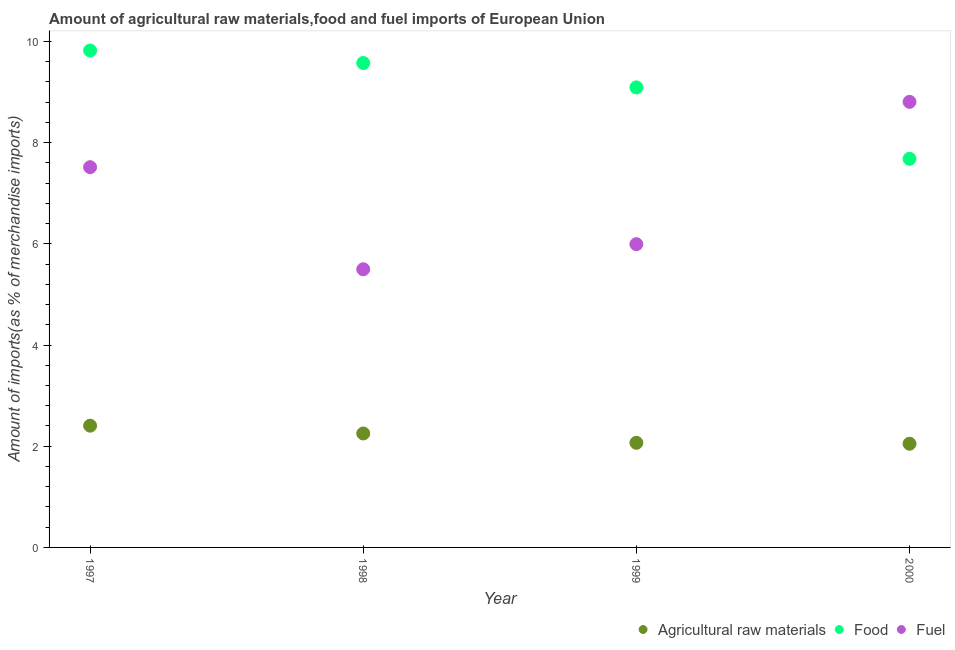Is the number of dotlines equal to the number of legend labels?
Give a very brief answer. Yes. What is the percentage of raw materials imports in 2000?
Your answer should be very brief. 2.05. Across all years, what is the maximum percentage of fuel imports?
Give a very brief answer. 8.81. Across all years, what is the minimum percentage of raw materials imports?
Your answer should be compact. 2.05. In which year was the percentage of food imports maximum?
Your response must be concise. 1997. In which year was the percentage of fuel imports minimum?
Keep it short and to the point. 1998. What is the total percentage of fuel imports in the graph?
Keep it short and to the point. 27.81. What is the difference between the percentage of raw materials imports in 1997 and that in 1998?
Provide a succinct answer. 0.15. What is the difference between the percentage of fuel imports in 1997 and the percentage of food imports in 2000?
Provide a short and direct response. -0.17. What is the average percentage of food imports per year?
Make the answer very short. 9.04. In the year 1998, what is the difference between the percentage of raw materials imports and percentage of food imports?
Make the answer very short. -7.32. In how many years, is the percentage of food imports greater than 2.8 %?
Ensure brevity in your answer.  4. What is the ratio of the percentage of fuel imports in 1997 to that in 1999?
Offer a terse response. 1.25. Is the difference between the percentage of raw materials imports in 1998 and 2000 greater than the difference between the percentage of fuel imports in 1998 and 2000?
Provide a succinct answer. Yes. What is the difference between the highest and the second highest percentage of fuel imports?
Your answer should be compact. 1.29. What is the difference between the highest and the lowest percentage of raw materials imports?
Give a very brief answer. 0.36. In how many years, is the percentage of fuel imports greater than the average percentage of fuel imports taken over all years?
Your answer should be compact. 2. Is it the case that in every year, the sum of the percentage of raw materials imports and percentage of food imports is greater than the percentage of fuel imports?
Offer a terse response. Yes. Is the percentage of fuel imports strictly greater than the percentage of raw materials imports over the years?
Your response must be concise. Yes. Is the percentage of food imports strictly less than the percentage of fuel imports over the years?
Give a very brief answer. No. How many dotlines are there?
Ensure brevity in your answer.  3. What is the difference between two consecutive major ticks on the Y-axis?
Your response must be concise. 2. Are the values on the major ticks of Y-axis written in scientific E-notation?
Make the answer very short. No. Does the graph contain any zero values?
Provide a short and direct response. No. Does the graph contain grids?
Provide a succinct answer. No. What is the title of the graph?
Make the answer very short. Amount of agricultural raw materials,food and fuel imports of European Union. What is the label or title of the Y-axis?
Provide a succinct answer. Amount of imports(as % of merchandise imports). What is the Amount of imports(as % of merchandise imports) of Agricultural raw materials in 1997?
Offer a very short reply. 2.41. What is the Amount of imports(as % of merchandise imports) in Food in 1997?
Your response must be concise. 9.82. What is the Amount of imports(as % of merchandise imports) of Fuel in 1997?
Give a very brief answer. 7.52. What is the Amount of imports(as % of merchandise imports) of Agricultural raw materials in 1998?
Offer a very short reply. 2.25. What is the Amount of imports(as % of merchandise imports) in Food in 1998?
Provide a succinct answer. 9.57. What is the Amount of imports(as % of merchandise imports) of Fuel in 1998?
Your response must be concise. 5.5. What is the Amount of imports(as % of merchandise imports) in Agricultural raw materials in 1999?
Provide a succinct answer. 2.07. What is the Amount of imports(as % of merchandise imports) in Food in 1999?
Provide a short and direct response. 9.09. What is the Amount of imports(as % of merchandise imports) of Fuel in 1999?
Give a very brief answer. 5.99. What is the Amount of imports(as % of merchandise imports) of Agricultural raw materials in 2000?
Provide a succinct answer. 2.05. What is the Amount of imports(as % of merchandise imports) in Food in 2000?
Provide a short and direct response. 7.68. What is the Amount of imports(as % of merchandise imports) in Fuel in 2000?
Your answer should be very brief. 8.81. Across all years, what is the maximum Amount of imports(as % of merchandise imports) in Agricultural raw materials?
Offer a terse response. 2.41. Across all years, what is the maximum Amount of imports(as % of merchandise imports) in Food?
Make the answer very short. 9.82. Across all years, what is the maximum Amount of imports(as % of merchandise imports) in Fuel?
Make the answer very short. 8.81. Across all years, what is the minimum Amount of imports(as % of merchandise imports) of Agricultural raw materials?
Give a very brief answer. 2.05. Across all years, what is the minimum Amount of imports(as % of merchandise imports) in Food?
Your response must be concise. 7.68. Across all years, what is the minimum Amount of imports(as % of merchandise imports) in Fuel?
Provide a succinct answer. 5.5. What is the total Amount of imports(as % of merchandise imports) in Agricultural raw materials in the graph?
Your response must be concise. 8.78. What is the total Amount of imports(as % of merchandise imports) in Food in the graph?
Give a very brief answer. 36.17. What is the total Amount of imports(as % of merchandise imports) of Fuel in the graph?
Offer a very short reply. 27.81. What is the difference between the Amount of imports(as % of merchandise imports) in Agricultural raw materials in 1997 and that in 1998?
Keep it short and to the point. 0.15. What is the difference between the Amount of imports(as % of merchandise imports) in Food in 1997 and that in 1998?
Your answer should be very brief. 0.25. What is the difference between the Amount of imports(as % of merchandise imports) of Fuel in 1997 and that in 1998?
Offer a terse response. 2.02. What is the difference between the Amount of imports(as % of merchandise imports) of Agricultural raw materials in 1997 and that in 1999?
Offer a terse response. 0.34. What is the difference between the Amount of imports(as % of merchandise imports) in Food in 1997 and that in 1999?
Ensure brevity in your answer.  0.73. What is the difference between the Amount of imports(as % of merchandise imports) of Fuel in 1997 and that in 1999?
Provide a succinct answer. 1.52. What is the difference between the Amount of imports(as % of merchandise imports) of Agricultural raw materials in 1997 and that in 2000?
Keep it short and to the point. 0.36. What is the difference between the Amount of imports(as % of merchandise imports) in Food in 1997 and that in 2000?
Make the answer very short. 2.14. What is the difference between the Amount of imports(as % of merchandise imports) in Fuel in 1997 and that in 2000?
Provide a succinct answer. -1.29. What is the difference between the Amount of imports(as % of merchandise imports) of Agricultural raw materials in 1998 and that in 1999?
Provide a short and direct response. 0.18. What is the difference between the Amount of imports(as % of merchandise imports) of Food in 1998 and that in 1999?
Keep it short and to the point. 0.48. What is the difference between the Amount of imports(as % of merchandise imports) in Fuel in 1998 and that in 1999?
Your answer should be very brief. -0.5. What is the difference between the Amount of imports(as % of merchandise imports) in Agricultural raw materials in 1998 and that in 2000?
Your answer should be very brief. 0.2. What is the difference between the Amount of imports(as % of merchandise imports) of Food in 1998 and that in 2000?
Ensure brevity in your answer.  1.89. What is the difference between the Amount of imports(as % of merchandise imports) of Fuel in 1998 and that in 2000?
Offer a very short reply. -3.31. What is the difference between the Amount of imports(as % of merchandise imports) in Agricultural raw materials in 1999 and that in 2000?
Offer a terse response. 0.02. What is the difference between the Amount of imports(as % of merchandise imports) of Food in 1999 and that in 2000?
Provide a succinct answer. 1.41. What is the difference between the Amount of imports(as % of merchandise imports) in Fuel in 1999 and that in 2000?
Make the answer very short. -2.81. What is the difference between the Amount of imports(as % of merchandise imports) in Agricultural raw materials in 1997 and the Amount of imports(as % of merchandise imports) in Food in 1998?
Your answer should be very brief. -7.17. What is the difference between the Amount of imports(as % of merchandise imports) of Agricultural raw materials in 1997 and the Amount of imports(as % of merchandise imports) of Fuel in 1998?
Offer a terse response. -3.09. What is the difference between the Amount of imports(as % of merchandise imports) in Food in 1997 and the Amount of imports(as % of merchandise imports) in Fuel in 1998?
Ensure brevity in your answer.  4.32. What is the difference between the Amount of imports(as % of merchandise imports) in Agricultural raw materials in 1997 and the Amount of imports(as % of merchandise imports) in Food in 1999?
Your response must be concise. -6.69. What is the difference between the Amount of imports(as % of merchandise imports) of Agricultural raw materials in 1997 and the Amount of imports(as % of merchandise imports) of Fuel in 1999?
Your answer should be very brief. -3.59. What is the difference between the Amount of imports(as % of merchandise imports) of Food in 1997 and the Amount of imports(as % of merchandise imports) of Fuel in 1999?
Ensure brevity in your answer.  3.83. What is the difference between the Amount of imports(as % of merchandise imports) in Agricultural raw materials in 1997 and the Amount of imports(as % of merchandise imports) in Food in 2000?
Your response must be concise. -5.27. What is the difference between the Amount of imports(as % of merchandise imports) of Agricultural raw materials in 1997 and the Amount of imports(as % of merchandise imports) of Fuel in 2000?
Make the answer very short. -6.4. What is the difference between the Amount of imports(as % of merchandise imports) in Food in 1997 and the Amount of imports(as % of merchandise imports) in Fuel in 2000?
Keep it short and to the point. 1.02. What is the difference between the Amount of imports(as % of merchandise imports) in Agricultural raw materials in 1998 and the Amount of imports(as % of merchandise imports) in Food in 1999?
Provide a short and direct response. -6.84. What is the difference between the Amount of imports(as % of merchandise imports) in Agricultural raw materials in 1998 and the Amount of imports(as % of merchandise imports) in Fuel in 1999?
Make the answer very short. -3.74. What is the difference between the Amount of imports(as % of merchandise imports) in Food in 1998 and the Amount of imports(as % of merchandise imports) in Fuel in 1999?
Make the answer very short. 3.58. What is the difference between the Amount of imports(as % of merchandise imports) of Agricultural raw materials in 1998 and the Amount of imports(as % of merchandise imports) of Food in 2000?
Provide a short and direct response. -5.43. What is the difference between the Amount of imports(as % of merchandise imports) of Agricultural raw materials in 1998 and the Amount of imports(as % of merchandise imports) of Fuel in 2000?
Ensure brevity in your answer.  -6.55. What is the difference between the Amount of imports(as % of merchandise imports) of Food in 1998 and the Amount of imports(as % of merchandise imports) of Fuel in 2000?
Give a very brief answer. 0.77. What is the difference between the Amount of imports(as % of merchandise imports) in Agricultural raw materials in 1999 and the Amount of imports(as % of merchandise imports) in Food in 2000?
Your answer should be compact. -5.61. What is the difference between the Amount of imports(as % of merchandise imports) of Agricultural raw materials in 1999 and the Amount of imports(as % of merchandise imports) of Fuel in 2000?
Your response must be concise. -6.74. What is the difference between the Amount of imports(as % of merchandise imports) of Food in 1999 and the Amount of imports(as % of merchandise imports) of Fuel in 2000?
Your answer should be very brief. 0.29. What is the average Amount of imports(as % of merchandise imports) of Agricultural raw materials per year?
Keep it short and to the point. 2.19. What is the average Amount of imports(as % of merchandise imports) of Food per year?
Provide a short and direct response. 9.04. What is the average Amount of imports(as % of merchandise imports) of Fuel per year?
Your response must be concise. 6.95. In the year 1997, what is the difference between the Amount of imports(as % of merchandise imports) in Agricultural raw materials and Amount of imports(as % of merchandise imports) in Food?
Offer a terse response. -7.42. In the year 1997, what is the difference between the Amount of imports(as % of merchandise imports) in Agricultural raw materials and Amount of imports(as % of merchandise imports) in Fuel?
Give a very brief answer. -5.11. In the year 1997, what is the difference between the Amount of imports(as % of merchandise imports) of Food and Amount of imports(as % of merchandise imports) of Fuel?
Provide a short and direct response. 2.31. In the year 1998, what is the difference between the Amount of imports(as % of merchandise imports) of Agricultural raw materials and Amount of imports(as % of merchandise imports) of Food?
Provide a succinct answer. -7.32. In the year 1998, what is the difference between the Amount of imports(as % of merchandise imports) in Agricultural raw materials and Amount of imports(as % of merchandise imports) in Fuel?
Ensure brevity in your answer.  -3.25. In the year 1998, what is the difference between the Amount of imports(as % of merchandise imports) of Food and Amount of imports(as % of merchandise imports) of Fuel?
Your response must be concise. 4.08. In the year 1999, what is the difference between the Amount of imports(as % of merchandise imports) of Agricultural raw materials and Amount of imports(as % of merchandise imports) of Food?
Your answer should be very brief. -7.03. In the year 1999, what is the difference between the Amount of imports(as % of merchandise imports) of Agricultural raw materials and Amount of imports(as % of merchandise imports) of Fuel?
Make the answer very short. -3.93. In the year 1999, what is the difference between the Amount of imports(as % of merchandise imports) of Food and Amount of imports(as % of merchandise imports) of Fuel?
Provide a short and direct response. 3.1. In the year 2000, what is the difference between the Amount of imports(as % of merchandise imports) of Agricultural raw materials and Amount of imports(as % of merchandise imports) of Food?
Your answer should be very brief. -5.63. In the year 2000, what is the difference between the Amount of imports(as % of merchandise imports) in Agricultural raw materials and Amount of imports(as % of merchandise imports) in Fuel?
Your answer should be compact. -6.76. In the year 2000, what is the difference between the Amount of imports(as % of merchandise imports) of Food and Amount of imports(as % of merchandise imports) of Fuel?
Your response must be concise. -1.12. What is the ratio of the Amount of imports(as % of merchandise imports) of Agricultural raw materials in 1997 to that in 1998?
Keep it short and to the point. 1.07. What is the ratio of the Amount of imports(as % of merchandise imports) of Food in 1997 to that in 1998?
Ensure brevity in your answer.  1.03. What is the ratio of the Amount of imports(as % of merchandise imports) of Fuel in 1997 to that in 1998?
Ensure brevity in your answer.  1.37. What is the ratio of the Amount of imports(as % of merchandise imports) in Agricultural raw materials in 1997 to that in 1999?
Offer a very short reply. 1.16. What is the ratio of the Amount of imports(as % of merchandise imports) of Food in 1997 to that in 1999?
Make the answer very short. 1.08. What is the ratio of the Amount of imports(as % of merchandise imports) in Fuel in 1997 to that in 1999?
Provide a succinct answer. 1.25. What is the ratio of the Amount of imports(as % of merchandise imports) in Agricultural raw materials in 1997 to that in 2000?
Offer a very short reply. 1.17. What is the ratio of the Amount of imports(as % of merchandise imports) in Food in 1997 to that in 2000?
Provide a short and direct response. 1.28. What is the ratio of the Amount of imports(as % of merchandise imports) of Fuel in 1997 to that in 2000?
Offer a terse response. 0.85. What is the ratio of the Amount of imports(as % of merchandise imports) in Agricultural raw materials in 1998 to that in 1999?
Keep it short and to the point. 1.09. What is the ratio of the Amount of imports(as % of merchandise imports) in Food in 1998 to that in 1999?
Make the answer very short. 1.05. What is the ratio of the Amount of imports(as % of merchandise imports) in Fuel in 1998 to that in 1999?
Keep it short and to the point. 0.92. What is the ratio of the Amount of imports(as % of merchandise imports) of Agricultural raw materials in 1998 to that in 2000?
Your answer should be compact. 1.1. What is the ratio of the Amount of imports(as % of merchandise imports) in Food in 1998 to that in 2000?
Ensure brevity in your answer.  1.25. What is the ratio of the Amount of imports(as % of merchandise imports) of Fuel in 1998 to that in 2000?
Give a very brief answer. 0.62. What is the ratio of the Amount of imports(as % of merchandise imports) in Agricultural raw materials in 1999 to that in 2000?
Your answer should be compact. 1.01. What is the ratio of the Amount of imports(as % of merchandise imports) of Food in 1999 to that in 2000?
Provide a short and direct response. 1.18. What is the ratio of the Amount of imports(as % of merchandise imports) in Fuel in 1999 to that in 2000?
Your answer should be very brief. 0.68. What is the difference between the highest and the second highest Amount of imports(as % of merchandise imports) in Agricultural raw materials?
Make the answer very short. 0.15. What is the difference between the highest and the second highest Amount of imports(as % of merchandise imports) of Food?
Your answer should be compact. 0.25. What is the difference between the highest and the second highest Amount of imports(as % of merchandise imports) of Fuel?
Offer a very short reply. 1.29. What is the difference between the highest and the lowest Amount of imports(as % of merchandise imports) of Agricultural raw materials?
Offer a very short reply. 0.36. What is the difference between the highest and the lowest Amount of imports(as % of merchandise imports) of Food?
Your answer should be very brief. 2.14. What is the difference between the highest and the lowest Amount of imports(as % of merchandise imports) of Fuel?
Your response must be concise. 3.31. 